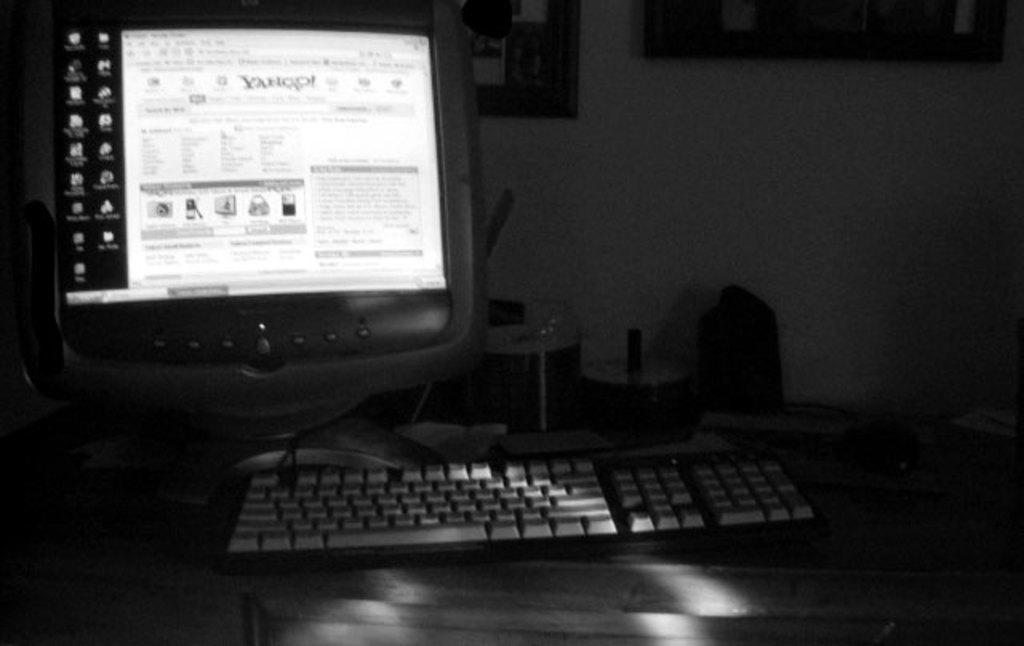<image>
Relay a brief, clear account of the picture shown. a computer with the screen turned on to the yahoo web page 